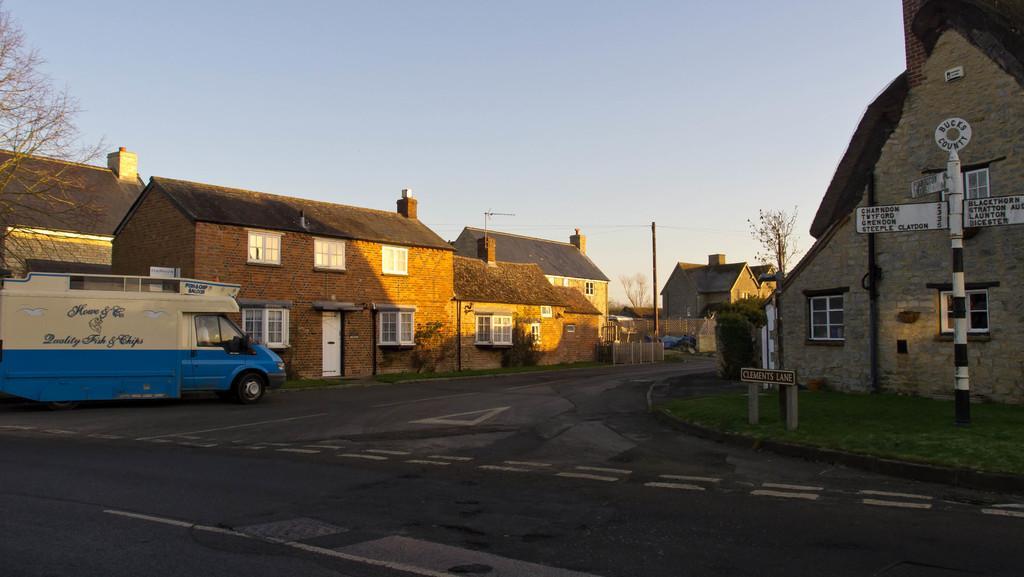In one or two sentences, can you explain what this image depicts? In this image there is a road, on that road there is a van, on either side of the road there are houses and trees, in the background there is the sky. 